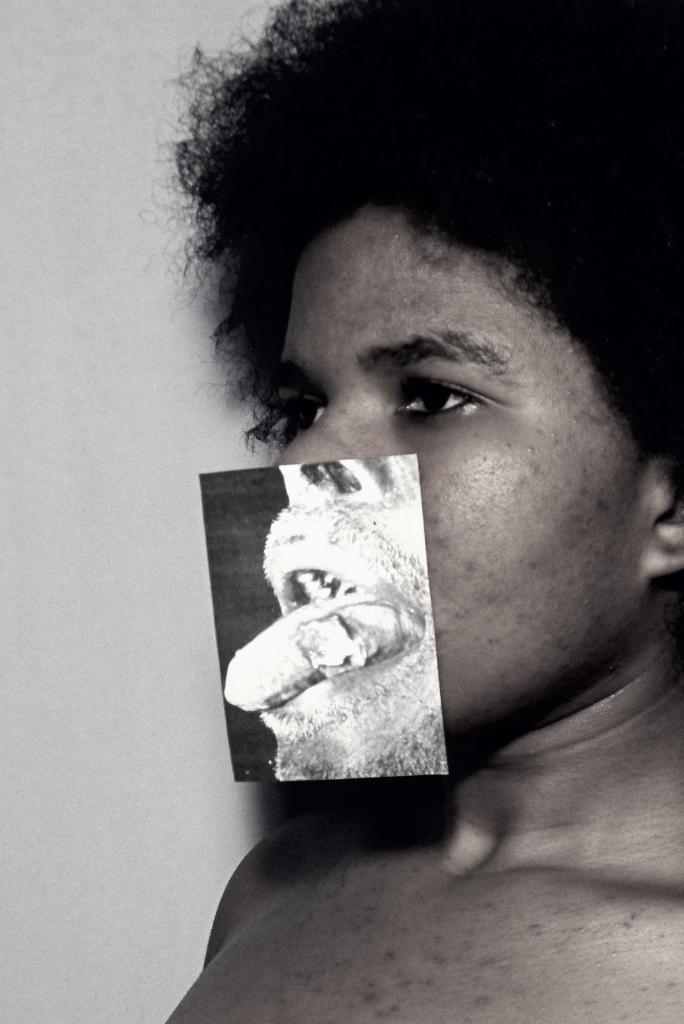Describe this image in one or two sentences. This is a black and white image, in this image there is a man, on his face there a picture of a mouth, in the background there is a wall. 